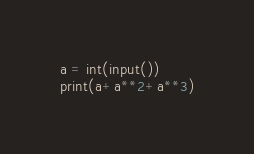<code> <loc_0><loc_0><loc_500><loc_500><_Python_>a = int(input())
print(a+a**2+a**3)</code> 